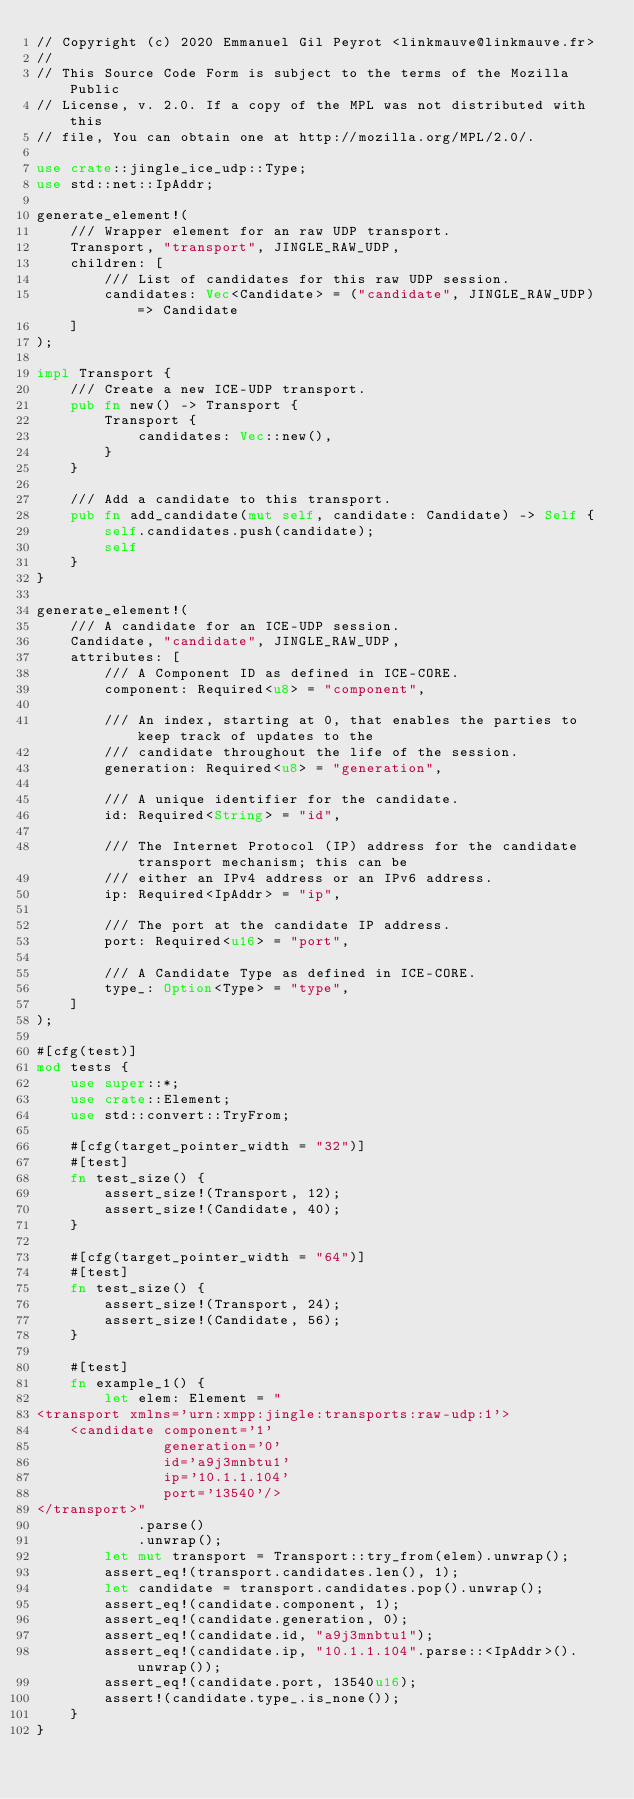<code> <loc_0><loc_0><loc_500><loc_500><_Rust_>// Copyright (c) 2020 Emmanuel Gil Peyrot <linkmauve@linkmauve.fr>
//
// This Source Code Form is subject to the terms of the Mozilla Public
// License, v. 2.0. If a copy of the MPL was not distributed with this
// file, You can obtain one at http://mozilla.org/MPL/2.0/.

use crate::jingle_ice_udp::Type;
use std::net::IpAddr;

generate_element!(
    /// Wrapper element for an raw UDP transport.
    Transport, "transport", JINGLE_RAW_UDP,
    children: [
        /// List of candidates for this raw UDP session.
        candidates: Vec<Candidate> = ("candidate", JINGLE_RAW_UDP) => Candidate
    ]
);

impl Transport {
    /// Create a new ICE-UDP transport.
    pub fn new() -> Transport {
        Transport {
            candidates: Vec::new(),
        }
    }

    /// Add a candidate to this transport.
    pub fn add_candidate(mut self, candidate: Candidate) -> Self {
        self.candidates.push(candidate);
        self
    }
}

generate_element!(
    /// A candidate for an ICE-UDP session.
    Candidate, "candidate", JINGLE_RAW_UDP,
    attributes: [
        /// A Component ID as defined in ICE-CORE.
        component: Required<u8> = "component",

        /// An index, starting at 0, that enables the parties to keep track of updates to the
        /// candidate throughout the life of the session.
        generation: Required<u8> = "generation",

        /// A unique identifier for the candidate.
        id: Required<String> = "id",

        /// The Internet Protocol (IP) address for the candidate transport mechanism; this can be
        /// either an IPv4 address or an IPv6 address.
        ip: Required<IpAddr> = "ip",

        /// The port at the candidate IP address.
        port: Required<u16> = "port",

        /// A Candidate Type as defined in ICE-CORE.
        type_: Option<Type> = "type",
    ]
);

#[cfg(test)]
mod tests {
    use super::*;
    use crate::Element;
    use std::convert::TryFrom;

    #[cfg(target_pointer_width = "32")]
    #[test]
    fn test_size() {
        assert_size!(Transport, 12);
        assert_size!(Candidate, 40);
    }

    #[cfg(target_pointer_width = "64")]
    #[test]
    fn test_size() {
        assert_size!(Transport, 24);
        assert_size!(Candidate, 56);
    }

    #[test]
    fn example_1() {
        let elem: Element = "
<transport xmlns='urn:xmpp:jingle:transports:raw-udp:1'>
    <candidate component='1'
               generation='0'
               id='a9j3mnbtu1'
               ip='10.1.1.104'
               port='13540'/>
</transport>"
            .parse()
            .unwrap();
        let mut transport = Transport::try_from(elem).unwrap();
        assert_eq!(transport.candidates.len(), 1);
        let candidate = transport.candidates.pop().unwrap();
        assert_eq!(candidate.component, 1);
        assert_eq!(candidate.generation, 0);
        assert_eq!(candidate.id, "a9j3mnbtu1");
        assert_eq!(candidate.ip, "10.1.1.104".parse::<IpAddr>().unwrap());
        assert_eq!(candidate.port, 13540u16);
        assert!(candidate.type_.is_none());
    }
}
</code> 